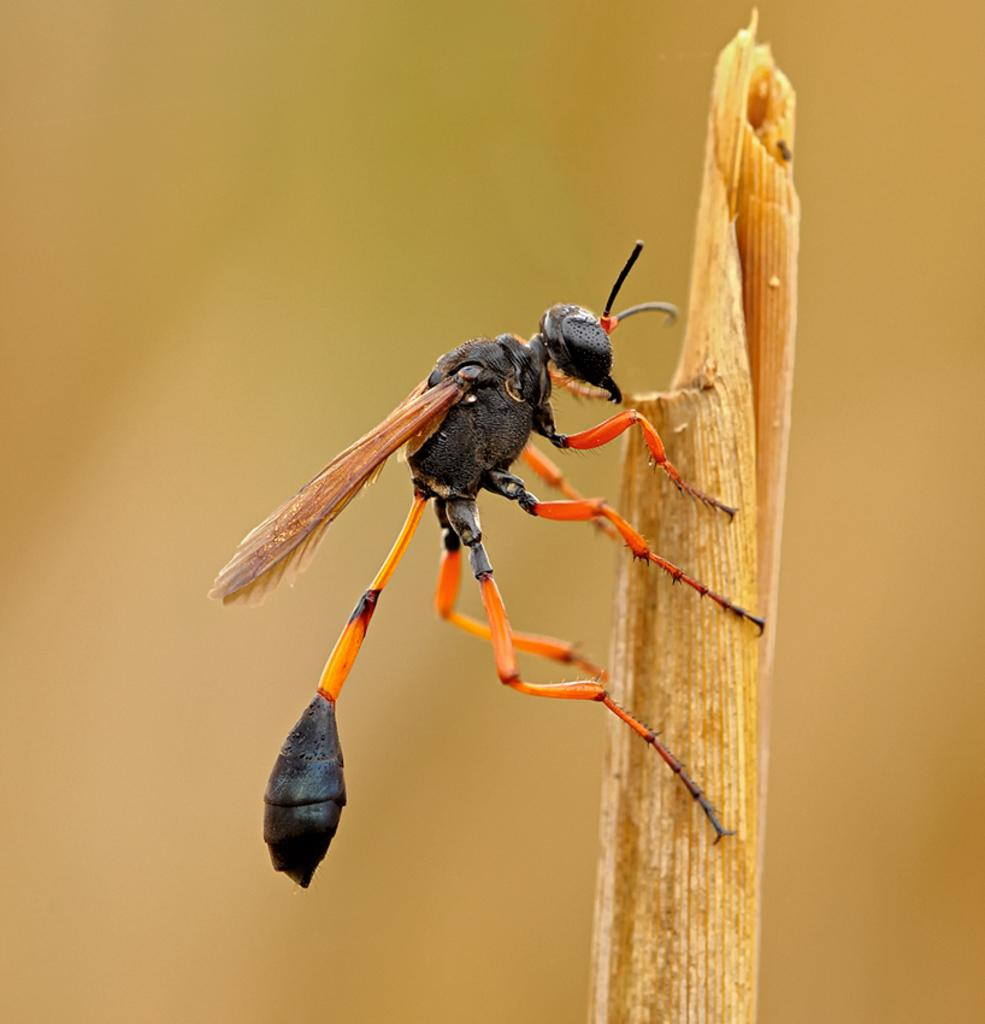What type of creature can be seen in the image? There is an insect in the image. Where is the insect located? The insect is on a stem. What can be observed about the background of the image? The background of the image is blurred. Can you see a snake slithering through the background of the image? No, there is no snake present in the image. The background is blurred, but it does not show a snake or any other creature besides the insect on the stem. 